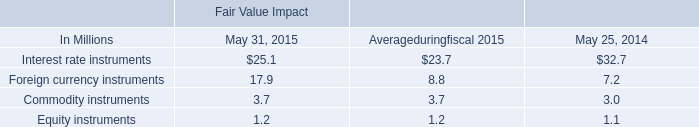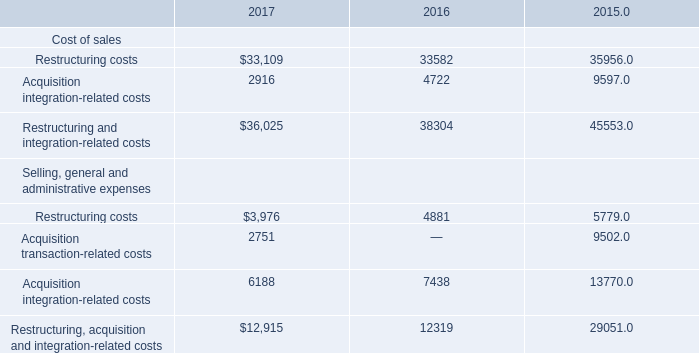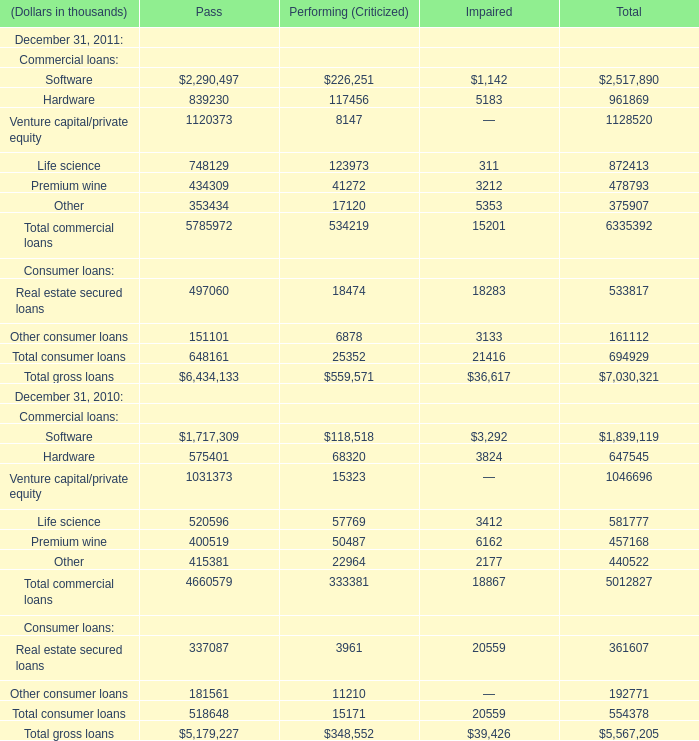In which year is Total commercial loans for Pass on December 31 greater than 5000000 thousand? 
Answer: 2011. 